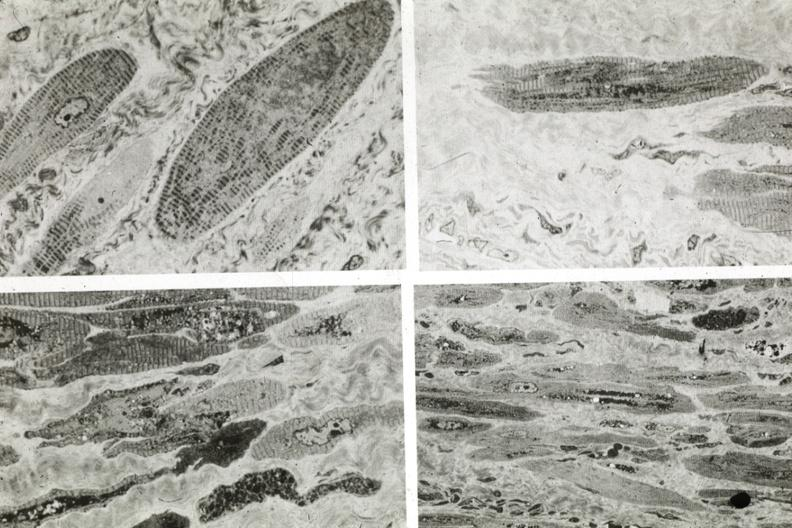what is present?
Answer the question using a single word or phrase. Cardiovascular 